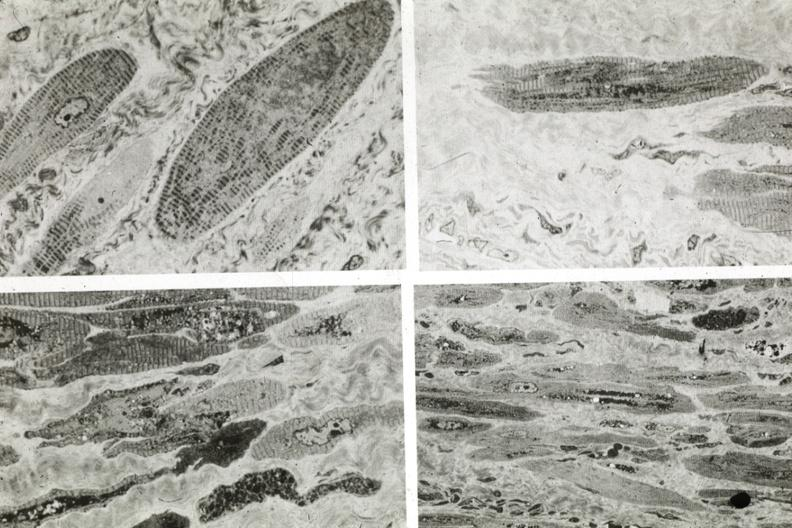what is present?
Answer the question using a single word or phrase. Cardiovascular 